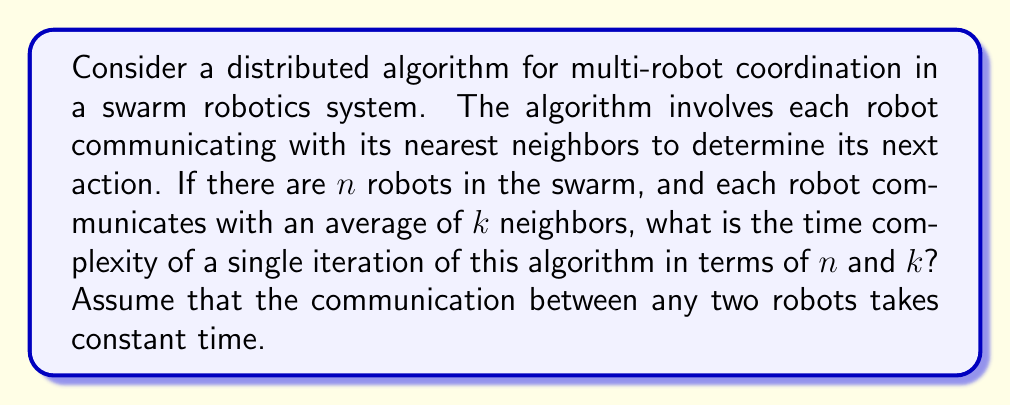Solve this math problem. To evaluate the efficiency of this distributed algorithm, we need to consider the following steps:

1) In a single iteration, each robot communicates with its nearest neighbors.

2) There are $n$ robots in total, and each robot communicates with an average of $k$ neighbors.

3) The communication between any two robots takes constant time, let's call this time $c$.

4) For a single robot, the time taken to communicate with its neighbors is $O(k)$, as it needs to communicate with $k$ neighbors, each taking constant time $c$.

5) Since all robots can perform their communications in parallel (as this is a distributed algorithm), the time complexity for a single iteration is not $O(nk)$, but rather $O(k)$.

6) However, we need to consider that in the worst case, the robot with the maximum number of neighbors will determine the overall time for an iteration. In a well-distributed system, this should still be close to $k$.

Therefore, the time complexity for a single iteration of this distributed algorithm is $O(k)$.

It's worth noting that while the time complexity is independent of $n$, the total amount of communication happening in the system scales with $n$. The message complexity (total number of messages sent in the system) would be $O(nk)$, but this doesn't affect the time complexity in a truly parallel, distributed system.
Answer: The time complexity of a single iteration of this distributed algorithm is $O(k)$, where $k$ is the average number of neighbors each robot communicates with. 